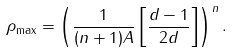Convert formula to latex. <formula><loc_0><loc_0><loc_500><loc_500>\rho _ { \max } = \left ( \frac { 1 } { ( n + 1 ) A } \left [ \frac { d - 1 } { 2 d } \right ] \right ) ^ { n } .</formula> 